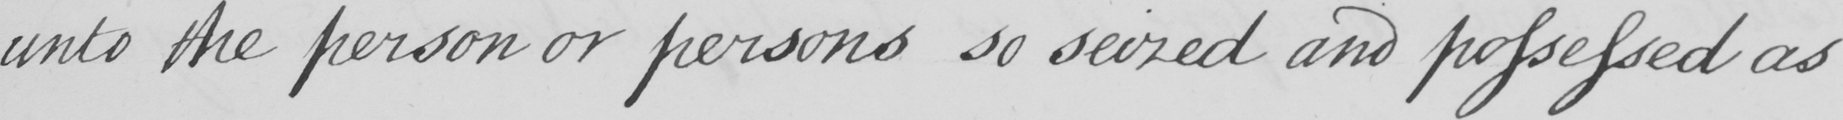Please provide the text content of this handwritten line. unto the person or persons so seized and possessed as 